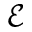<formula> <loc_0><loc_0><loc_500><loc_500>\mathcal { E }</formula> 